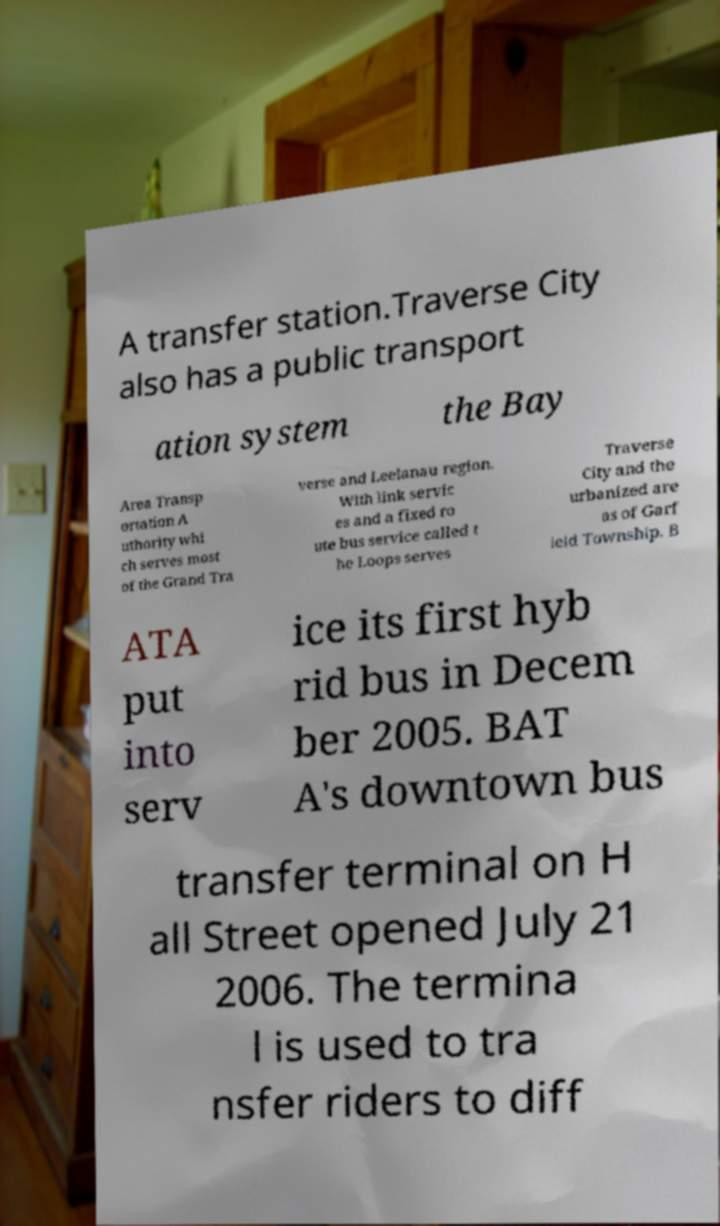Could you assist in decoding the text presented in this image and type it out clearly? A transfer station.Traverse City also has a public transport ation system the Bay Area Transp ortation A uthority whi ch serves most of the Grand Tra verse and Leelanau region. With link servic es and a fixed ro ute bus service called t he Loops serves Traverse City and the urbanized are as of Garf ield Township. B ATA put into serv ice its first hyb rid bus in Decem ber 2005. BAT A's downtown bus transfer terminal on H all Street opened July 21 2006. The termina l is used to tra nsfer riders to diff 